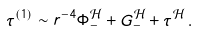Convert formula to latex. <formula><loc_0><loc_0><loc_500><loc_500>\tau ^ { ( 1 ) } \sim r ^ { - 4 } \Phi _ { - } ^ { \mathcal { H } } + G _ { - } ^ { \mathcal { H } } + \tau ^ { \mathcal { H } } \, .</formula> 